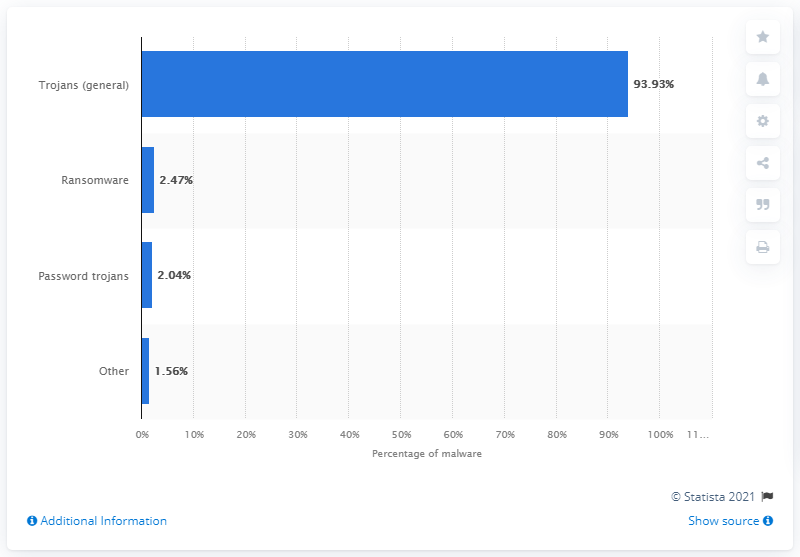Mention a couple of crucial points in this snapshot. In 2019, trojans were responsible for 93.93% of all malware attacks on Android systems. The second most common type of malware attack on Android in 2019 was ransomware. 